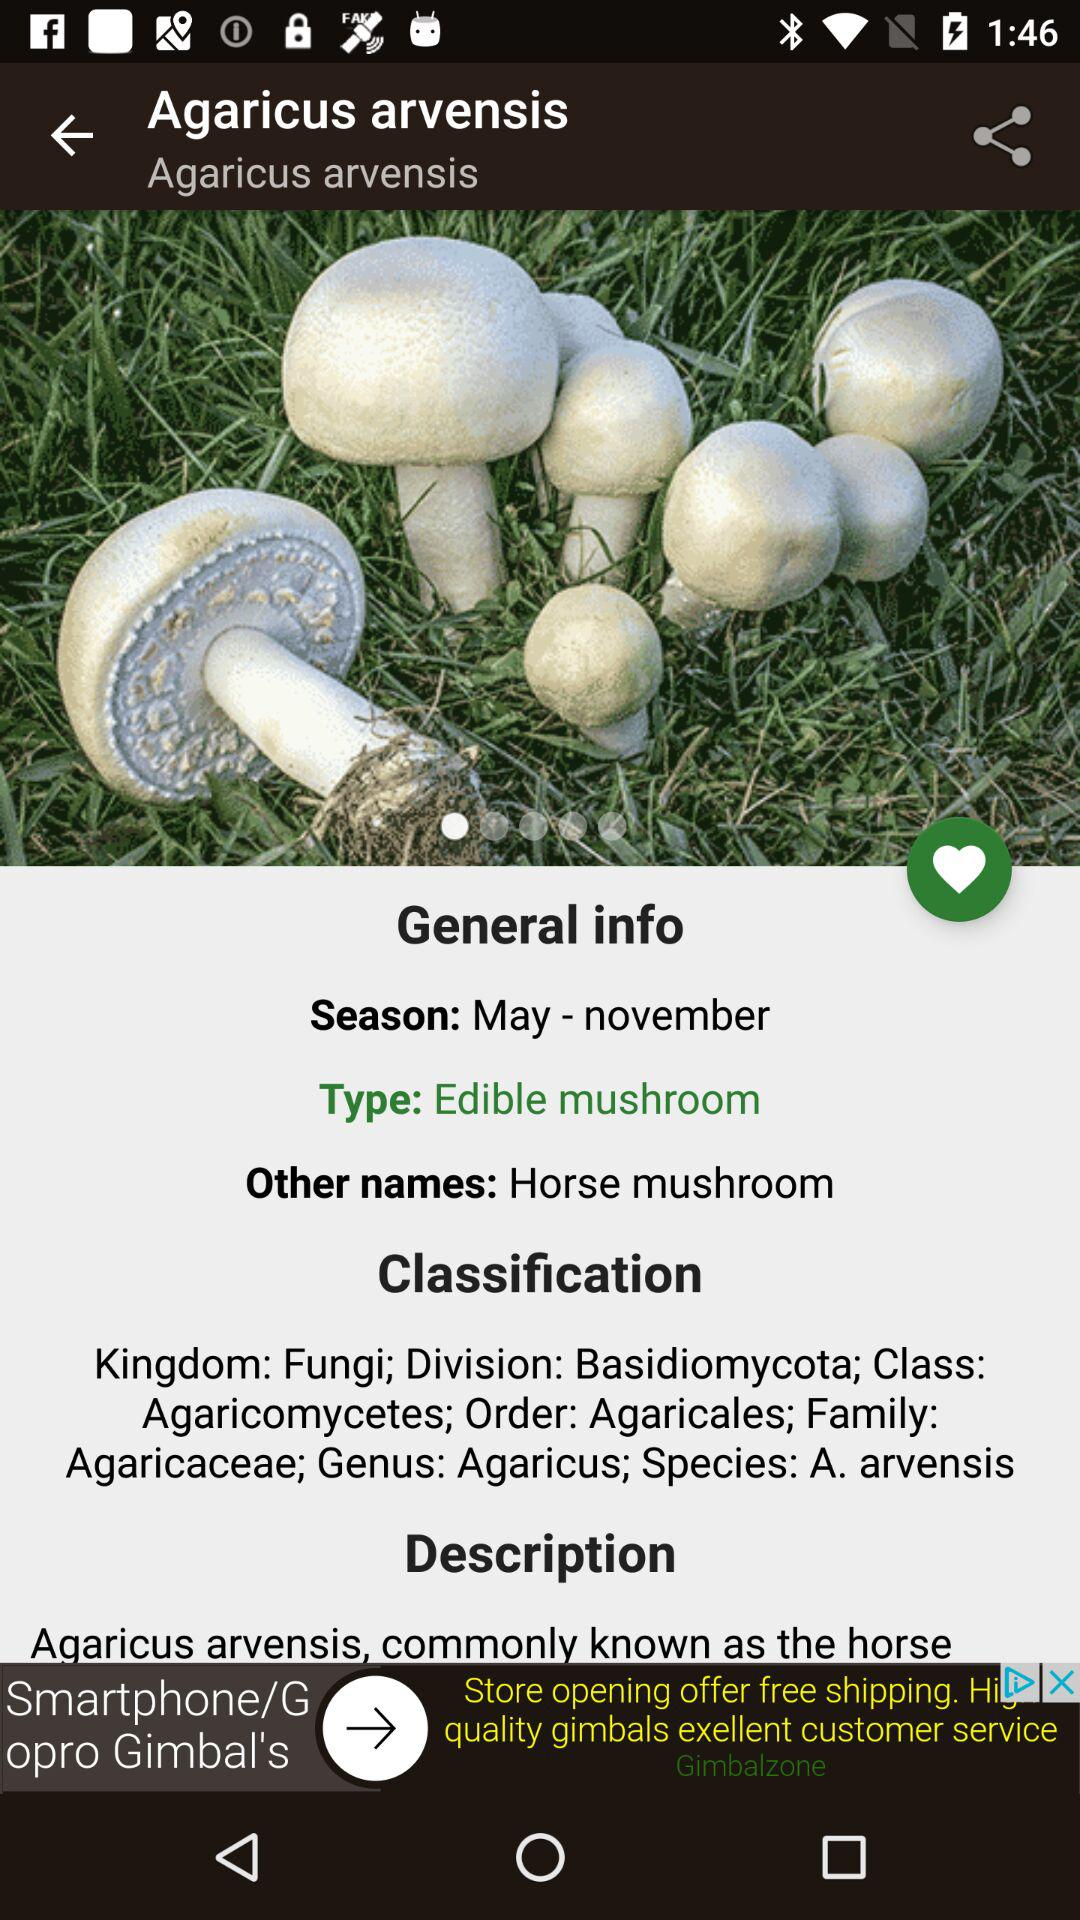What is the other name for Agaricus arvensis? The other name for Agaricus arvensis is Horse mushroom. 